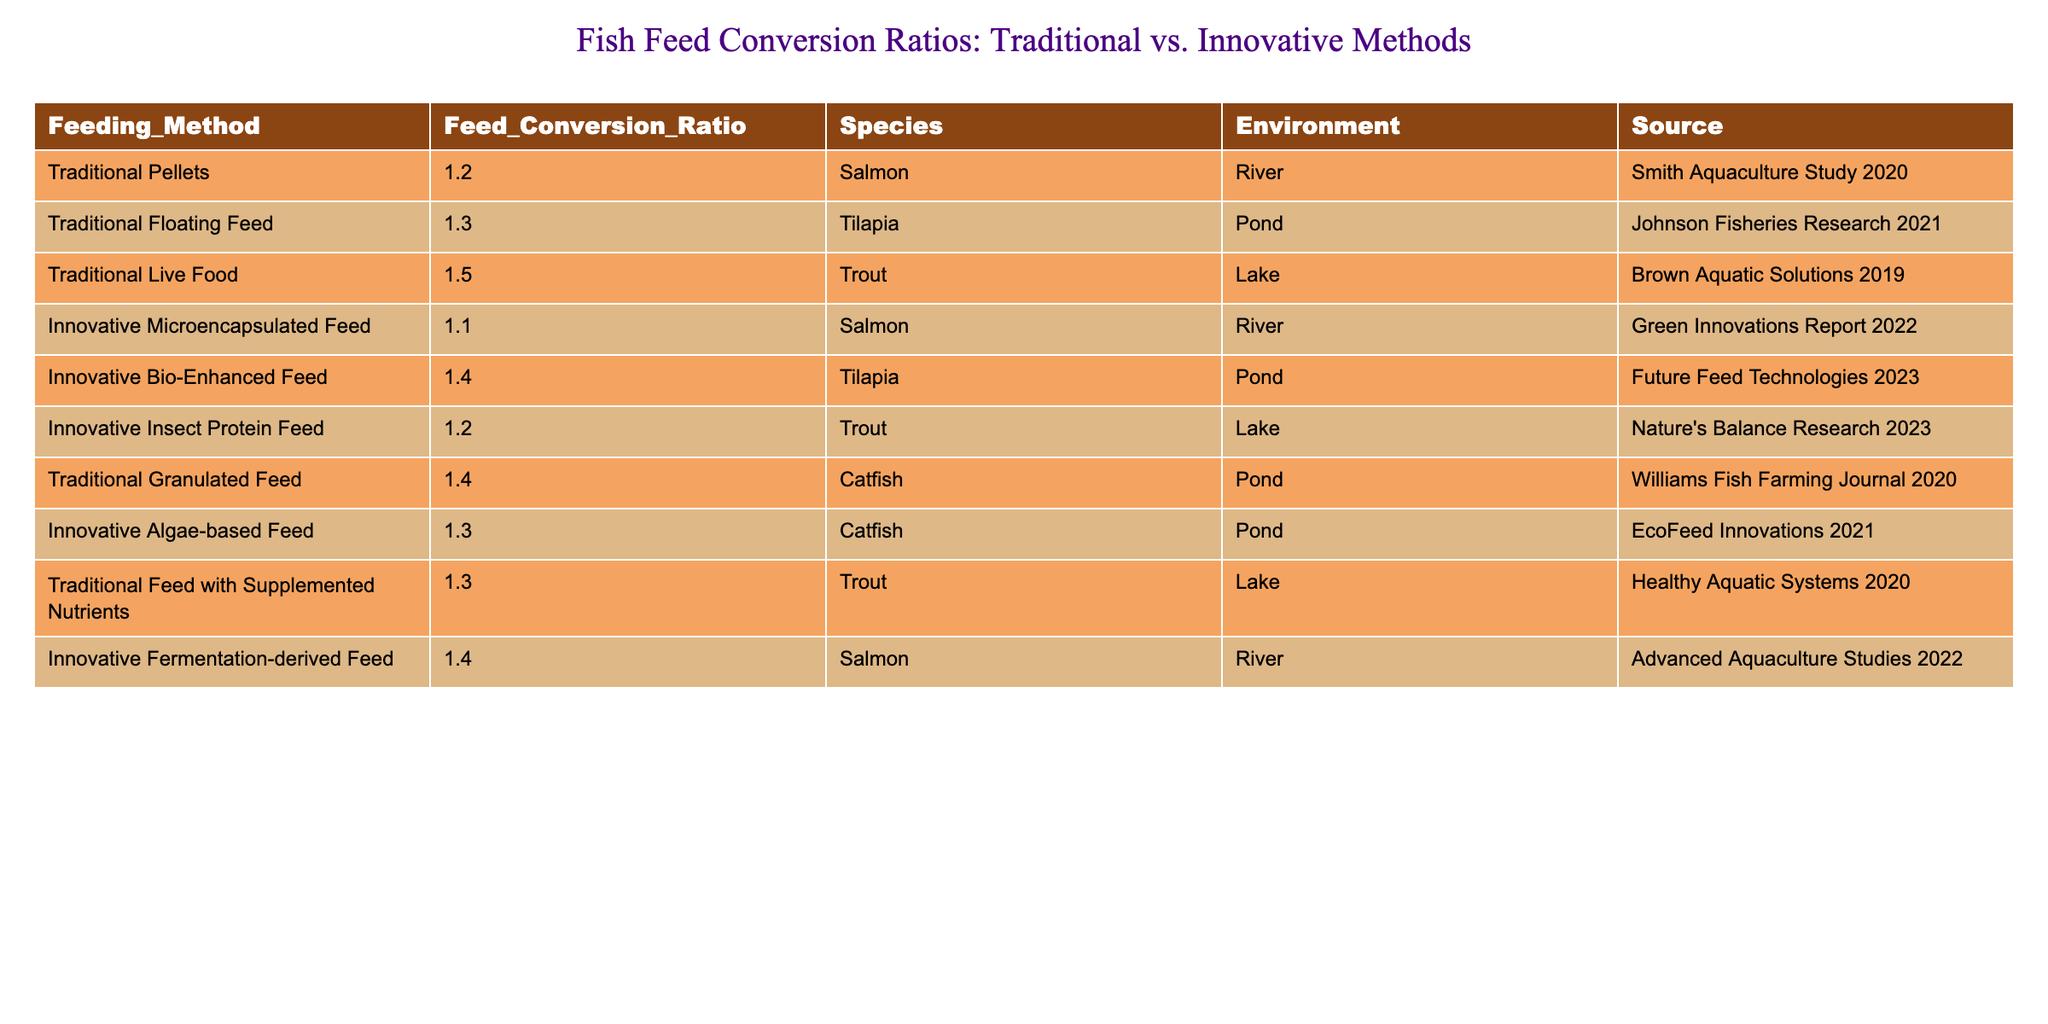What is the feed conversion ratio for traditional pellets used for salmon? The table shows that the feed conversion ratio for traditional pellets used for salmon is listed under the "Feed_Conversion_Ratio" column next to "Traditional Pellets." It is 1.2.
Answer: 1.2 Which feeding method has the highest feed conversion ratio for trout? The table includes multiple entries for trout. By comparing the feed conversion ratios for trout, we see that "Traditional Live Food" has the highest feed conversion ratio at 1.5.
Answer: 1.5 Is the feed conversion ratio for innovative microencapsulated feed lower than that for traditional floating feed? The ratio for innovative microencapsulated feed is 1.1, while the ratio for traditional floating feed is 1.3. Since 1.1 is less than 1.3, the statement is true.
Answer: Yes What is the average feed conversion ratio for all traditional feeding methods? The traditional methods and their ratios are: Pellets (1.2), Floating Feed (1.3), Live Food (1.5), Granulated Feed (1.4), and Feed with Supplemented Nutrients (1.3). Summing these gives 1.2 + 1.3 + 1.5 + 1.4 + 1.3 = 6.7. Dividing by 5 gives an average of 6.7 / 5 = 1.34.
Answer: 1.34 Which species has the lowest feed conversion ratio using traditional methods? The table lists the ratios for traditional methods for different species. The lowest ratio for traditional methods is 1.2 for Salmon (Traditional Pellets).
Answer: Salmon Is there a traditional method that has a higher feed conversion ratio than all innovative methods? The highest innovative feed conversion ratio is 1.4 for both Bio-Enhanced and Fermentation-derived feed. The highest traditional feed conversion ratio is 1.5 for Live Food. Since 1.5 is greater than 1.4, the statement is true.
Answer: Yes What is the total feed conversion ratio for all innovative methods combined? The innovative feeding methods are: Microencapsulated (1.1), Bio-Enhanced (1.4), Insect Protein (1.2), Algae-based (1.3), and Fermentation-derived (1.4). We add these ratios: 1.1 + 1.4 + 1.2 + 1.3 + 1.4 = 6.4.
Answer: 6.4 